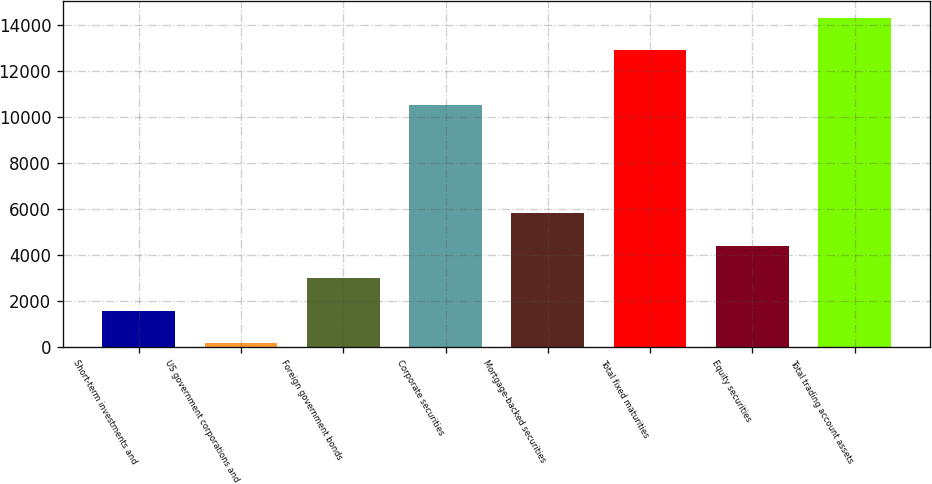Convert chart. <chart><loc_0><loc_0><loc_500><loc_500><bar_chart><fcel>Short-term investments and<fcel>US government corporations and<fcel>Foreign government bonds<fcel>Corporate securities<fcel>Mortgage-backed securities<fcel>Total fixed maturities<fcel>Equity securities<fcel>Total trading account assets<nl><fcel>1583.7<fcel>175<fcel>2992.4<fcel>10507<fcel>5809.8<fcel>12906<fcel>4401.1<fcel>14314.7<nl></chart> 